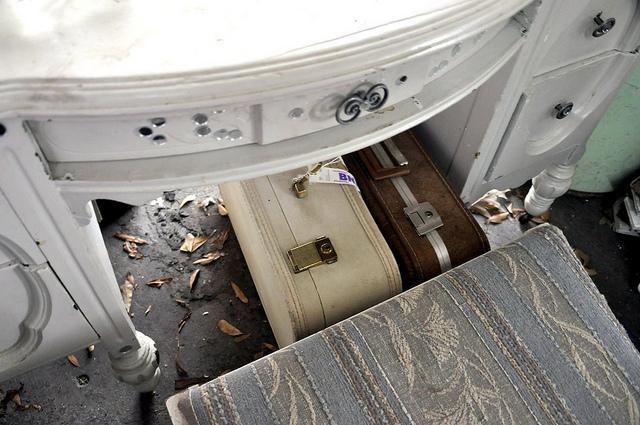How many suitcases are there?
Give a very brief answer. 3. How many keyboards are there?
Give a very brief answer. 0. 